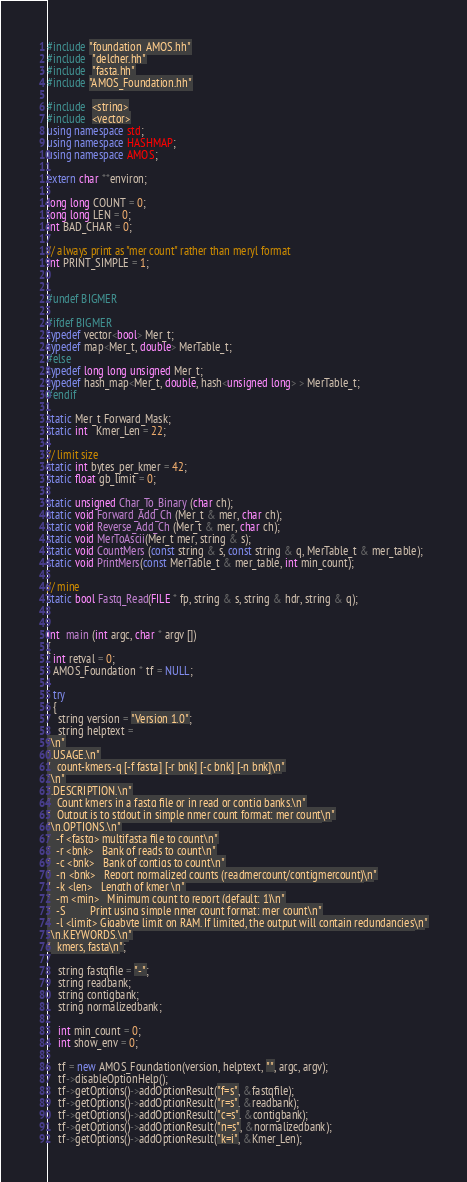Convert code to text. <code><loc_0><loc_0><loc_500><loc_500><_C++_>#include "foundation_AMOS.hh"
#include  "delcher.hh"
#include  "fasta.hh"
#include "AMOS_Foundation.hh"

#include  <string>
#include  <vector>
using namespace std;
using namespace HASHMAP;
using namespace AMOS;

extern char **environ;

long long COUNT = 0;
long long LEN = 0;
int BAD_CHAR = 0;

// always print as "mer count" rather than meryl format
int PRINT_SIMPLE = 1;


#undef BIGMER

#ifdef BIGMER
typedef vector<bool> Mer_t;
typedef map<Mer_t, double> MerTable_t;
#else
typedef long long unsigned Mer_t;
typedef hash_map<Mer_t, double, hash<unsigned long> > MerTable_t;
#endif

static Mer_t Forward_Mask;
static int   Kmer_Len = 22;

// limit size
static int bytes_per_kmer = 42;
static float gb_limit = 0;

static unsigned Char_To_Binary (char ch);
static void Forward_Add_Ch (Mer_t & mer, char ch);
static void Reverse_Add_Ch (Mer_t & mer, char ch);
static void MerToAscii(Mer_t mer, string & s);
static void CountMers (const string & s, const string & q, MerTable_t & mer_table);
static void PrintMers(const MerTable_t & mer_table, int min_count);

// mine
static bool Fastq_Read(FILE * fp, string & s, string & hdr, string & q);


int  main (int argc, char * argv [])
{
  int retval = 0;
  AMOS_Foundation * tf = NULL;

  try
  {
    string version = "Version 1.0";
    string helptext = 
"\n"
".USAGE.\n"
"  count-kmers-q [-f fasta] [-r bnk] [-c bnk] [-n bnk]\n"
"\n"
".DESCRIPTION.\n"
"  Count kmers in a fastq file or in read or contig banks.\n"
"  Output is to stdout in simple nmer count format: mer count\n"
"\n.OPTIONS.\n"
"  -f <fastq> multifasta file to count\n"
"  -r <bnk>   Bank of reads to count\n"
"  -c <bnk>   Bank of contigs to count\n"
"  -n <bnk>   Report normalized counts (readmercount/contigmercount)\n"
"  -k <len>   Length of kmer \n"
"  -m <min>   Minimum count to report (default: 1)\n"
"  -S         Print using simple nmer count format: mer count\n"
"  -l <limit> Gigabyte limit on RAM. If limited, the output will contain redundancies\n"
"\n.KEYWORDS.\n"
"  kmers, fasta\n";

    string fastqfile = "-";
    string readbank;
    string contigbank;
    string normalizedbank;

    int min_count = 0;
    int show_env = 0;

    tf = new AMOS_Foundation(version, helptext, "", argc, argv);
    tf->disableOptionHelp();
    tf->getOptions()->addOptionResult("f=s", &fastqfile);
    tf->getOptions()->addOptionResult("r=s", &readbank);
    tf->getOptions()->addOptionResult("c=s", &contigbank);
    tf->getOptions()->addOptionResult("n=s", &normalizedbank);
    tf->getOptions()->addOptionResult("k=i", &Kmer_Len);</code> 